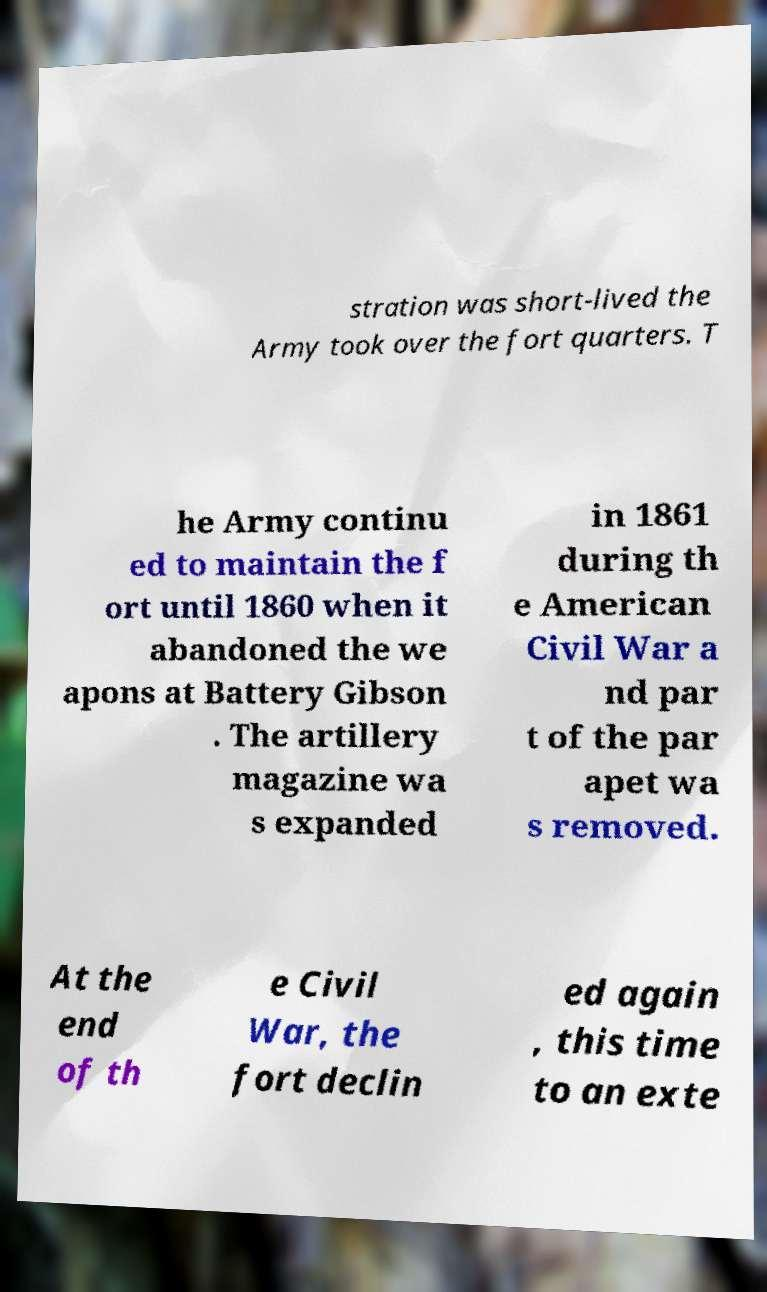There's text embedded in this image that I need extracted. Can you transcribe it verbatim? stration was short-lived the Army took over the fort quarters. T he Army continu ed to maintain the f ort until 1860 when it abandoned the we apons at Battery Gibson . The artillery magazine wa s expanded in 1861 during th e American Civil War a nd par t of the par apet wa s removed. At the end of th e Civil War, the fort declin ed again , this time to an exte 